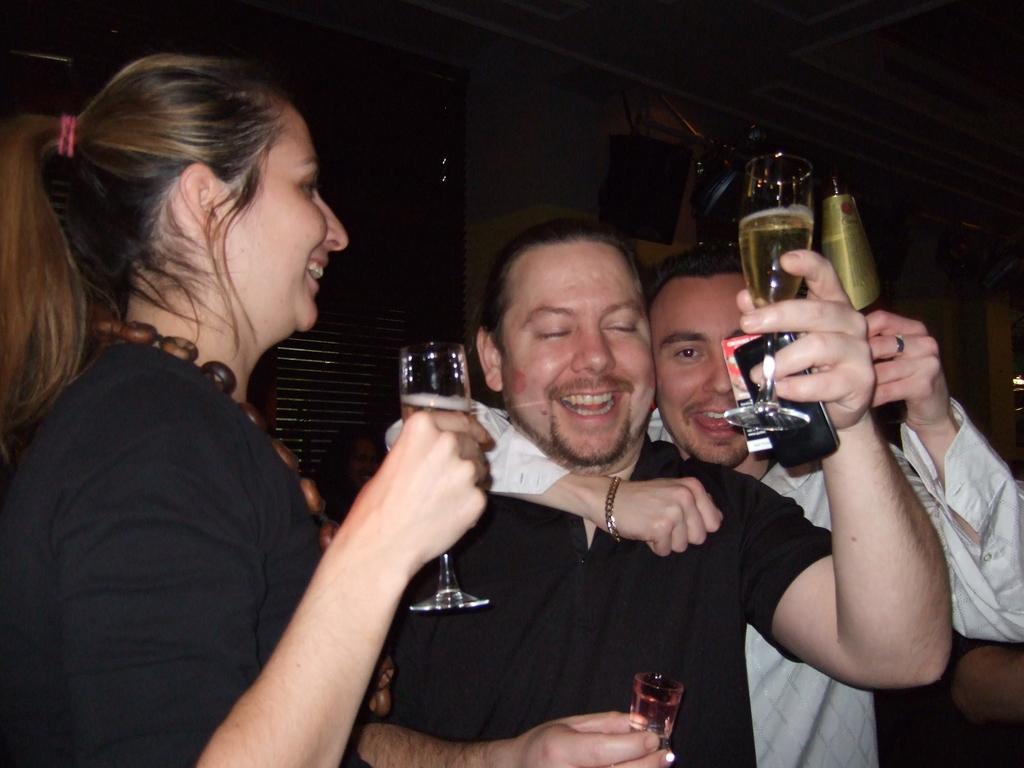Please provide a concise description of this image. In this image in front there are people holding the wine glasses and they were smiling. Behind them there is a wall. Beside the wall there is a wooden door. 